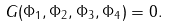Convert formula to latex. <formula><loc_0><loc_0><loc_500><loc_500>G ( \Phi _ { 1 } , \Phi _ { 2 } , \Phi _ { 3 } , \Phi _ { 4 } ) = 0 .</formula> 